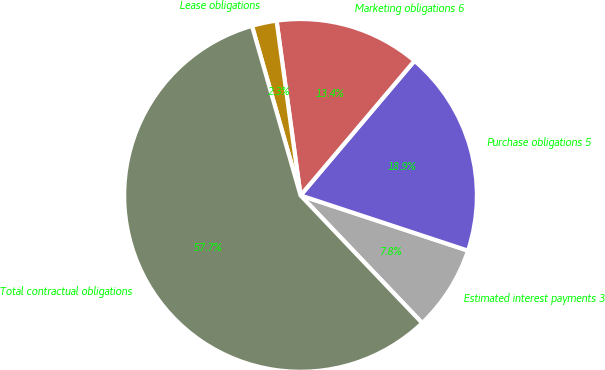Convert chart to OTSL. <chart><loc_0><loc_0><loc_500><loc_500><pie_chart><fcel>Estimated interest payments 3<fcel>Purchase obligations 5<fcel>Marketing obligations 6<fcel>Lease obligations<fcel>Total contractual obligations<nl><fcel>7.81%<fcel>18.89%<fcel>13.35%<fcel>2.27%<fcel>57.67%<nl></chart> 